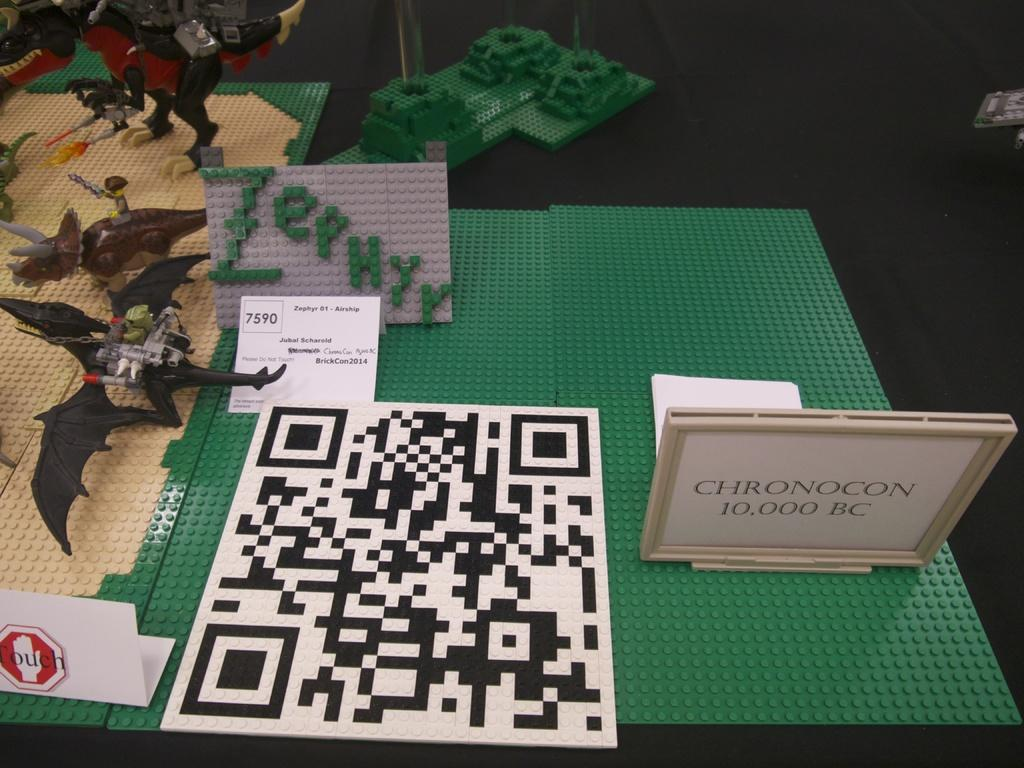What type of objects can be seen in the image? There are toys and lego objects in the image. What is the color of the surface on which the objects are placed? The surface is black. Are there any boards visible in the image? Yes, there are boards on the black surface. What additional feature can be found in the image? A QR code is visible in the image. Can you see a squirrel holding a bottle in the image? No, there is no squirrel or bottle present in the image. What type of net is used to catch the lego objects in the image? There is no net visible in the image; the lego objects are placed on boards on a black surface. 